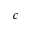Convert formula to latex. <formula><loc_0><loc_0><loc_500><loc_500>c</formula> 